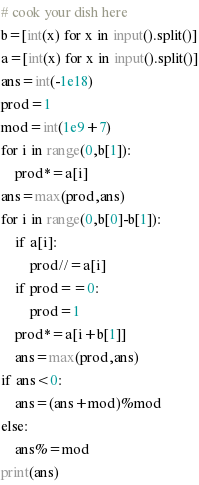<code> <loc_0><loc_0><loc_500><loc_500><_Python_># cook your dish here
b=[int(x) for x in input().split()]
a=[int(x) for x in input().split()]
ans=int(-1e18)
prod=1 
mod=int(1e9+7)
for i in range(0,b[1]): 
    prod*=a[i]
ans=max(prod,ans)
for i in range(0,b[0]-b[1]): 
    if a[i]:
        prod//=a[i]
    if prod==0:
        prod=1
    prod*=a[i+b[1]]
    ans=max(prod,ans)  
if ans<0:
    ans=(ans+mod)%mod 
else:
    ans%=mod 
print(ans)</code> 